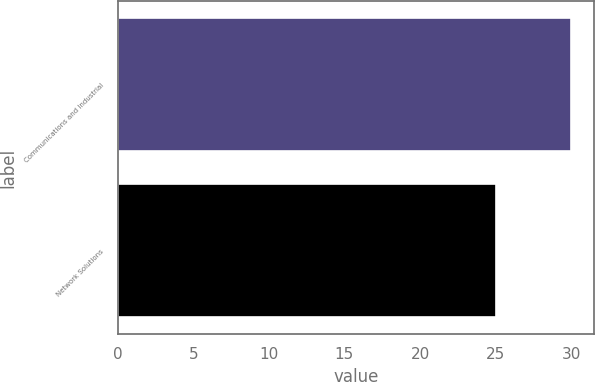Convert chart to OTSL. <chart><loc_0><loc_0><loc_500><loc_500><bar_chart><fcel>Communications and Industrial<fcel>Network Solutions<nl><fcel>30<fcel>25<nl></chart> 